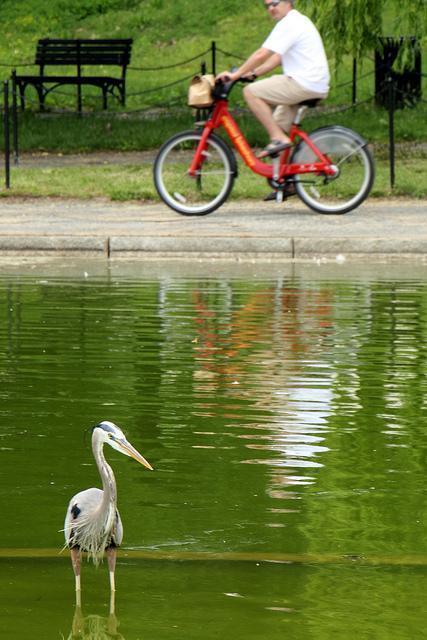At What location is the biker riding by the bird?
Make your selection from the four choices given to correctly answer the question.
Options: Chicken hut, city street, market, park. Park. 